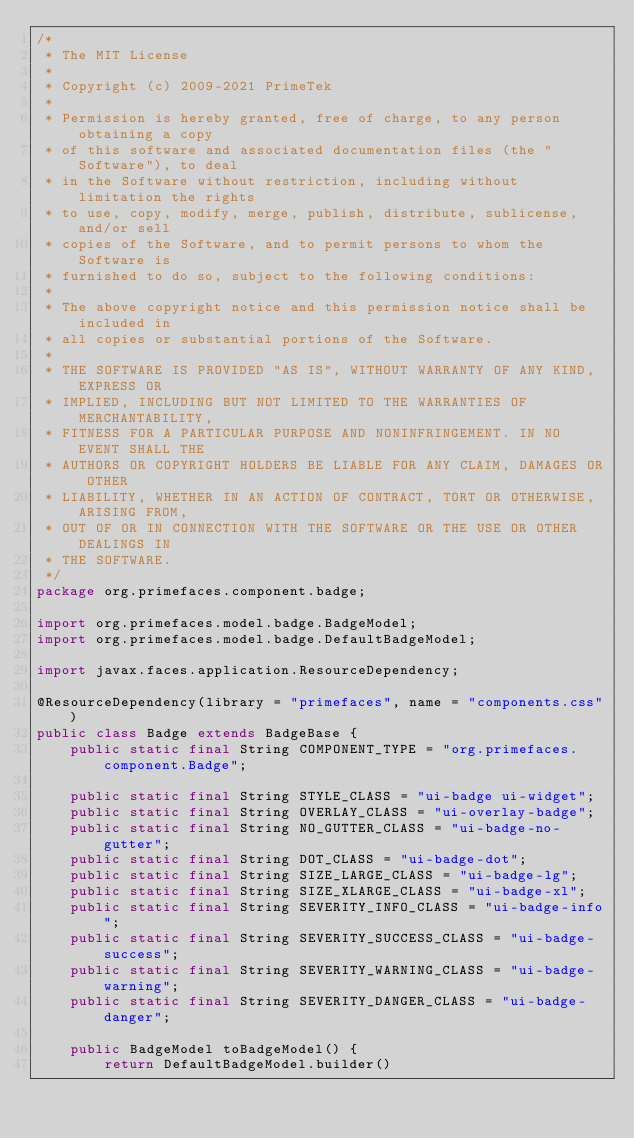<code> <loc_0><loc_0><loc_500><loc_500><_Java_>/*
 * The MIT License
 *
 * Copyright (c) 2009-2021 PrimeTek
 *
 * Permission is hereby granted, free of charge, to any person obtaining a copy
 * of this software and associated documentation files (the "Software"), to deal
 * in the Software without restriction, including without limitation the rights
 * to use, copy, modify, merge, publish, distribute, sublicense, and/or sell
 * copies of the Software, and to permit persons to whom the Software is
 * furnished to do so, subject to the following conditions:
 *
 * The above copyright notice and this permission notice shall be included in
 * all copies or substantial portions of the Software.
 *
 * THE SOFTWARE IS PROVIDED "AS IS", WITHOUT WARRANTY OF ANY KIND, EXPRESS OR
 * IMPLIED, INCLUDING BUT NOT LIMITED TO THE WARRANTIES OF MERCHANTABILITY,
 * FITNESS FOR A PARTICULAR PURPOSE AND NONINFRINGEMENT. IN NO EVENT SHALL THE
 * AUTHORS OR COPYRIGHT HOLDERS BE LIABLE FOR ANY CLAIM, DAMAGES OR OTHER
 * LIABILITY, WHETHER IN AN ACTION OF CONTRACT, TORT OR OTHERWISE, ARISING FROM,
 * OUT OF OR IN CONNECTION WITH THE SOFTWARE OR THE USE OR OTHER DEALINGS IN
 * THE SOFTWARE.
 */
package org.primefaces.component.badge;

import org.primefaces.model.badge.BadgeModel;
import org.primefaces.model.badge.DefaultBadgeModel;

import javax.faces.application.ResourceDependency;

@ResourceDependency(library = "primefaces", name = "components.css")
public class Badge extends BadgeBase {
    public static final String COMPONENT_TYPE = "org.primefaces.component.Badge";

    public static final String STYLE_CLASS = "ui-badge ui-widget";
    public static final String OVERLAY_CLASS = "ui-overlay-badge";
    public static final String NO_GUTTER_CLASS = "ui-badge-no-gutter";
    public static final String DOT_CLASS = "ui-badge-dot";
    public static final String SIZE_LARGE_CLASS = "ui-badge-lg";
    public static final String SIZE_XLARGE_CLASS = "ui-badge-xl";
    public static final String SEVERITY_INFO_CLASS = "ui-badge-info";
    public static final String SEVERITY_SUCCESS_CLASS = "ui-badge-success";
    public static final String SEVERITY_WARNING_CLASS = "ui-badge-warning";
    public static final String SEVERITY_DANGER_CLASS = "ui-badge-danger";

    public BadgeModel toBadgeModel() {
        return DefaultBadgeModel.builder()</code> 